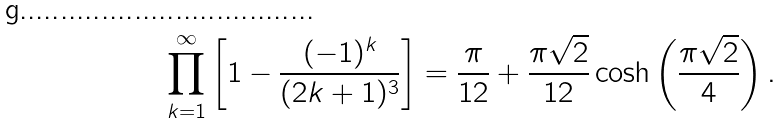Convert formula to latex. <formula><loc_0><loc_0><loc_500><loc_500>\prod _ { k = 1 } ^ { \infty } \left [ 1 - \frac { ( - 1 ) ^ { k } } { ( 2 k + 1 ) ^ { 3 } } \right ] = \frac { \pi } { 1 2 } + \frac { \pi \sqrt { 2 } } { 1 2 } \cosh \left ( \frac { \pi \sqrt { 2 } } { 4 } \right ) .</formula> 